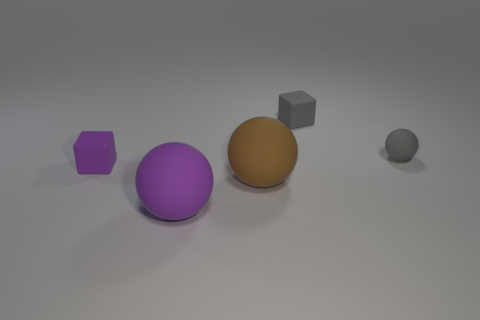Subtract all gray balls. Subtract all blue cylinders. How many balls are left? 2 Subtract all purple cubes. How many red balls are left? 0 Add 4 greens. How many big purples exist? 0 Subtract all large purple spheres. Subtract all large red metal balls. How many objects are left? 4 Add 2 small gray blocks. How many small gray blocks are left? 3 Add 5 big brown rubber things. How many big brown rubber things exist? 6 Add 1 small purple matte cylinders. How many objects exist? 6 Subtract all gray balls. How many balls are left? 2 Subtract all small gray matte balls. How many balls are left? 2 Subtract 0 brown cylinders. How many objects are left? 5 